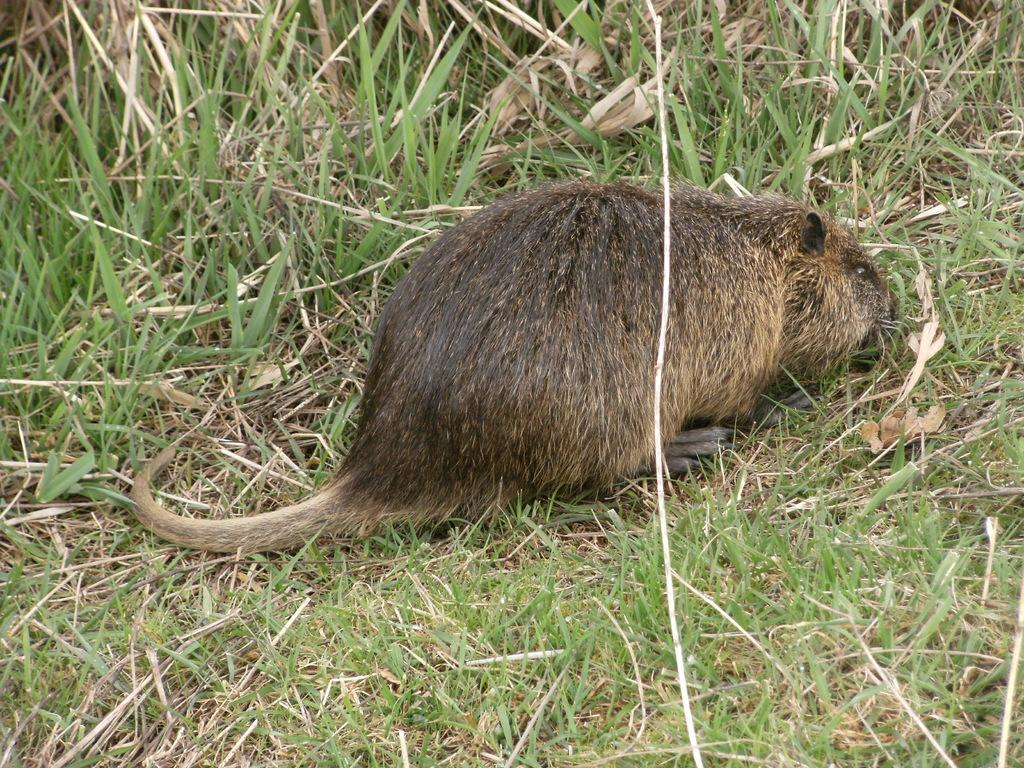What type of animal is in the picture? A: The specific type of animal cannot be determined from the provided facts. Where is the animal located in the picture? The animal is on the grass. Can you describe the condition of the grass? The grass appears to be dry. What scent is the animal emitting in the picture? There is no information about the scent of the animal in the picture. 